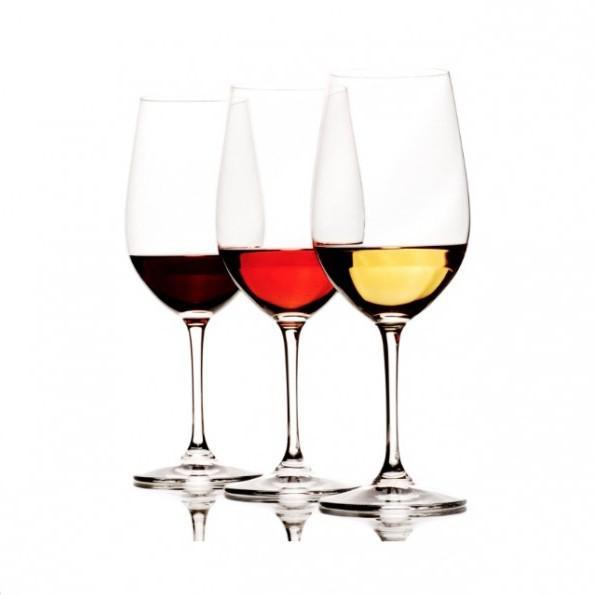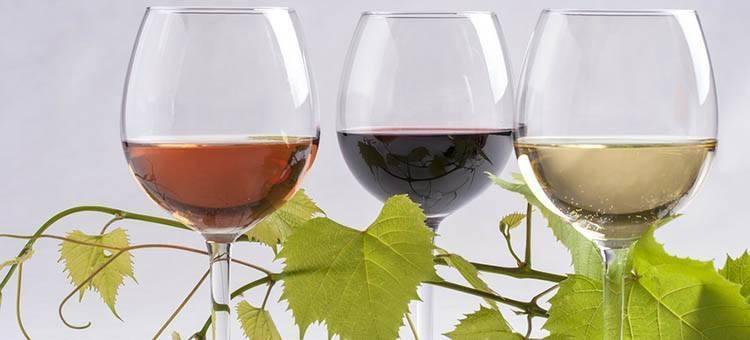The first image is the image on the left, the second image is the image on the right. Assess this claim about the two images: "One image contains four glasses of different colors of wine.". Correct or not? Answer yes or no. No. The first image is the image on the left, the second image is the image on the right. Analyze the images presented: Is the assertion "There are four glasses of liquid in one of the images." valid? Answer yes or no. No. 